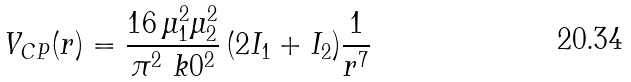<formula> <loc_0><loc_0><loc_500><loc_500>V _ { C P } ( r ) = \frac { 1 6 \, \mu ^ { 2 } _ { 1 } \mu ^ { 2 } _ { 2 } } { \pi ^ { 2 } \ k 0 ^ { 2 } } \, ( 2 I _ { 1 } + I _ { 2 } ) \frac { 1 } { r ^ { 7 } }</formula> 